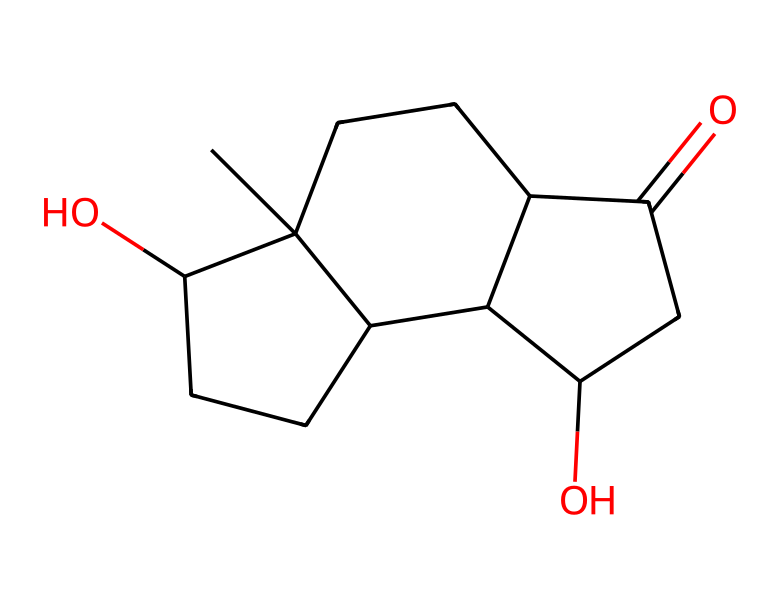What is the molecular formula of estradiol? To determine the molecular formula, we need to count the number of carbon (C), hydrogen (H), and oxygen (O) atoms from the chemical structure represented by the SMILES. Counting from the SMILES, we find 18 carbon atoms, 24 hydrogen atoms, and 2 oxygen atoms, which gives us the molecular formula C18H24O2.
Answer: C18H24O2 How many rings are present in the structure? By observing the SMILES, we can identify the numbers that denote ring connections (1, 2, and 3 in this case). These indicate that there are three interconnected rings. Thus, the structure has three distinct rings.
Answer: 3 What functional groups are present in estradiol? The structure includes hydroxyl groups (-OH) associated with the two oxygen atoms indicated in the SMILES. These hydroxyl groups contribute to the phenolic nature of estradiol, characterizing it as a steroid with alcohol functionality as well.
Answer: hydroxyl groups What is the significance of the hydroxyl groups in estradiol? The presence of hydroxyl groups in estradiol is crucial as they increase the solubility of the compound in water and play an essential role in the hormone's biological activity, influencing estrogen receptor binding and activity.
Answer: biological activity Which part of the structure indicates it is a steroid? The tetracyclic core structure, which consists of four fused rings, is distinctive for steroids. The presence of these four hydrophobic rings is a defining feature, confirming that estradiol belongs to the steroid class.
Answer: tetracyclic core 